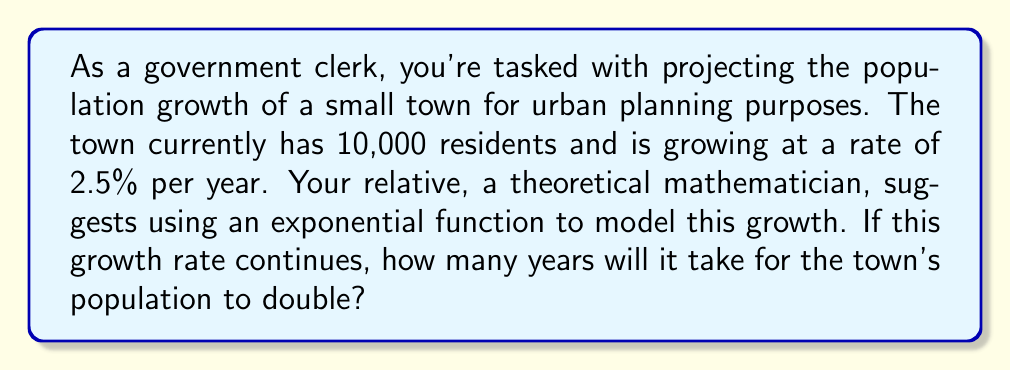Provide a solution to this math problem. To solve this problem, we'll use the exponential growth function and the concept of doubling time. Let's approach this step-by-step:

1) The exponential growth function is given by:
   $$P(t) = P_0 \cdot e^{rt}$$
   where $P(t)$ is the population at time $t$, $P_0$ is the initial population, $r$ is the growth rate, and $t$ is the time in years.

2) We're given:
   $P_0 = 10,000$
   $r = 2.5\% = 0.025$

3) We want to find $t$ when the population doubles, so:
   $$P(t) = 2P_0 = 2 \cdot 10,000 = 20,000$$

4) Substituting into the exponential growth equation:
   $$20,000 = 10,000 \cdot e^{0.025t}$$

5) Simplify:
   $$2 = e^{0.025t}$$

6) Take the natural log of both sides:
   $$\ln(2) = 0.025t$$

7) Solve for $t$:
   $$t = \frac{\ln(2)}{0.025} \approx 27.73$$

Therefore, it will take approximately 27.73 years for the population to double.

This practical application demonstrates how theoretical mathematical concepts (exponential functions) can be applied to real-world governance issues (urban planning).
Answer: Approximately 27.73 years 